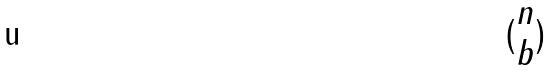Convert formula to latex. <formula><loc_0><loc_0><loc_500><loc_500>( \begin{matrix} n \\ b \end{matrix} )</formula> 